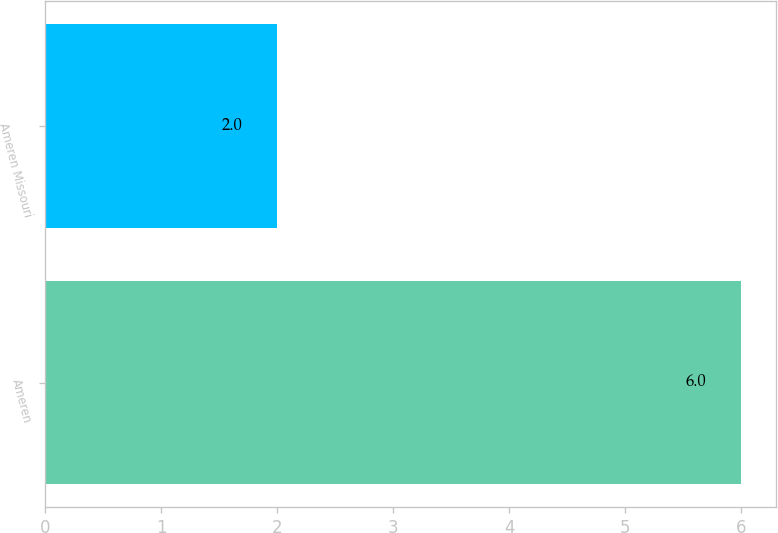<chart> <loc_0><loc_0><loc_500><loc_500><bar_chart><fcel>Ameren<fcel>Ameren Missouri<nl><fcel>6<fcel>2<nl></chart> 